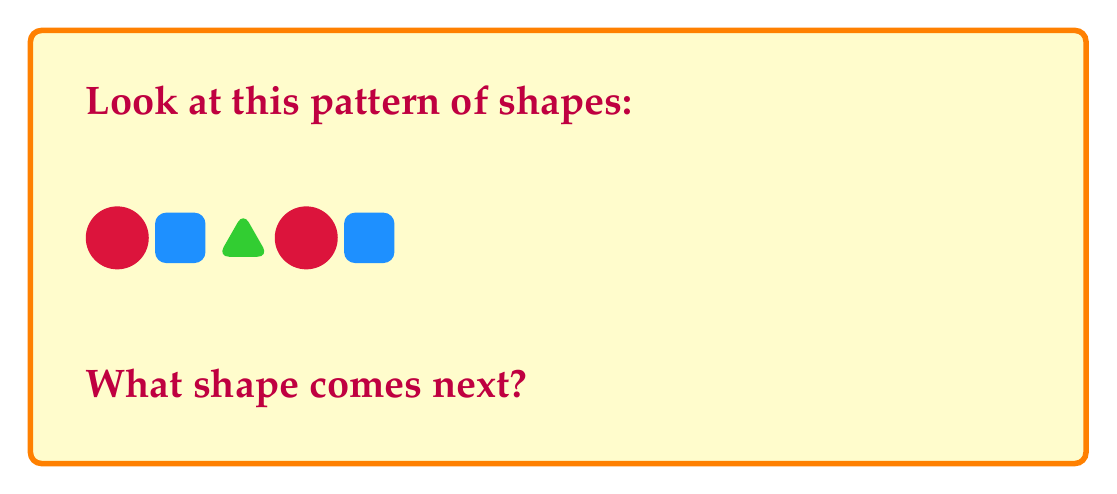Teach me how to tackle this problem. Let's look at the pattern step by step:

1. First, we have a red circle.
2. Then, a blue square.
3. Next, a green triangle.
4. Then, the pattern starts over with a red circle.
5. Finally, we see a blue square.

We can see that the pattern repeats every 3 shapes:
- Circle (red)
- Square (blue)
- Triangle (green)

Since we've just seen a square, the next shape in the pattern would be a triangle.

To remember this pattern, you can think of it as "Circle, Square, Triangle" or "Red, Blue, Green". The colors and shapes always go together in this order.
Answer: A green triangle 